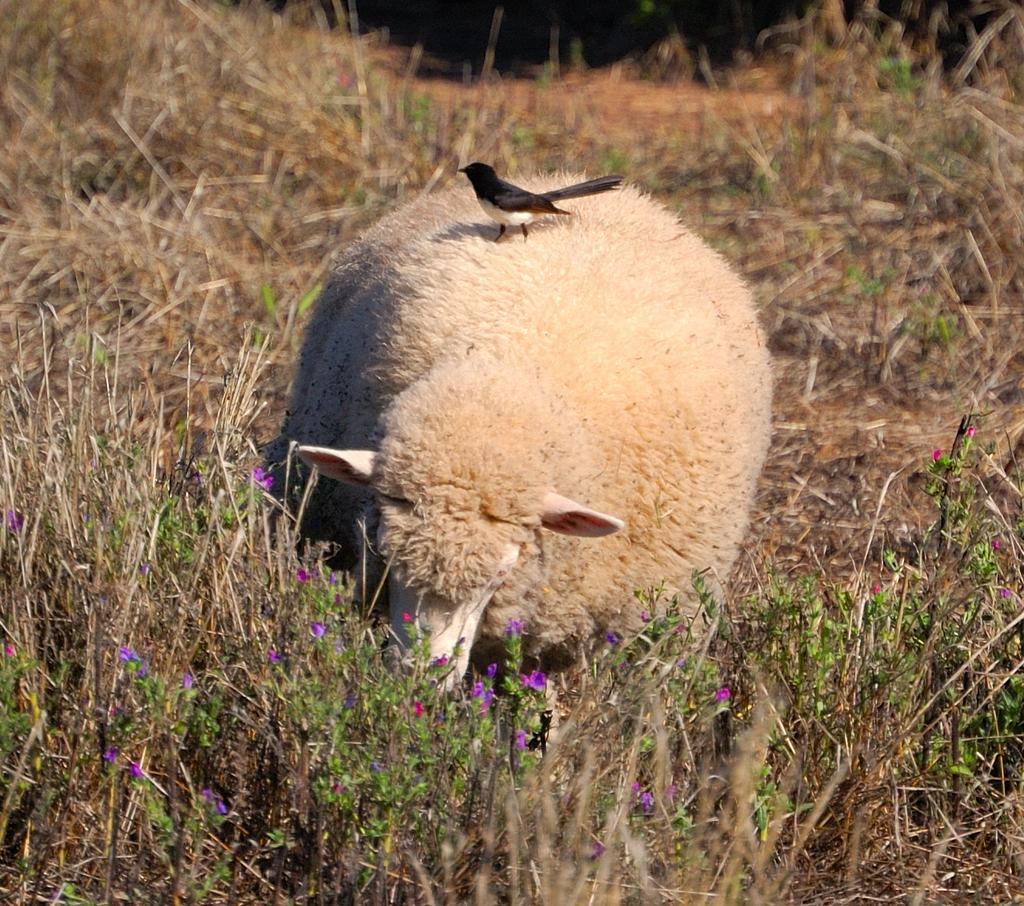What type of living organisms can be seen in the image? Plants and flowers are visible in the image. What other animals can be seen in the image besides plants? There is a white color sheep and a bird in the image. Can you tell me how the sheep is laughing in the image? Sheep do not laugh, and there is no indication in the image that the sheep is laughing. 